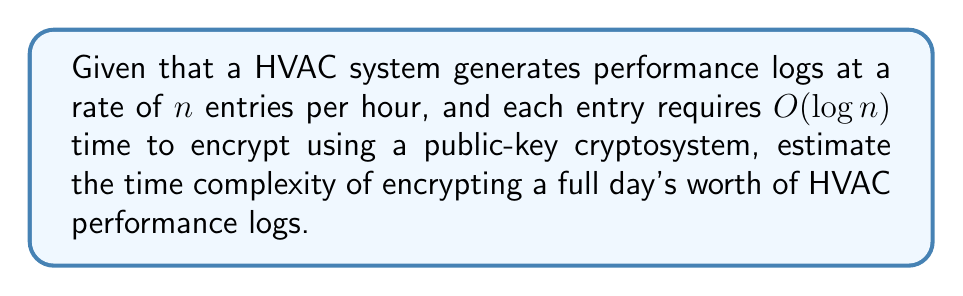Help me with this question. To solve this problem, we need to follow these steps:

1. Calculate the total number of log entries for a full day:
   - Number of entries per day = $n * 24$ (since there are 24 hours in a day)

2. Determine the time complexity for encrypting a single entry:
   - Time complexity for one entry = $O(\log n)$

3. Calculate the total time complexity for encrypting all entries in a day:
   - Total time complexity = (Number of entries) * (Time complexity per entry)
   - Total time complexity = $(n * 24) * O(\log n)$
   - Total time complexity = $O(24n \log n)$

4. Simplify the expression:
   - Since 24 is a constant, we can remove it from the big O notation
   - Simplified time complexity = $O(n \log n)$

Therefore, the time complexity of encrypting a full day's worth of HVAC performance logs is $O(n \log n)$, where $n$ is the number of log entries generated per hour.
Answer: $O(n \log n)$ 